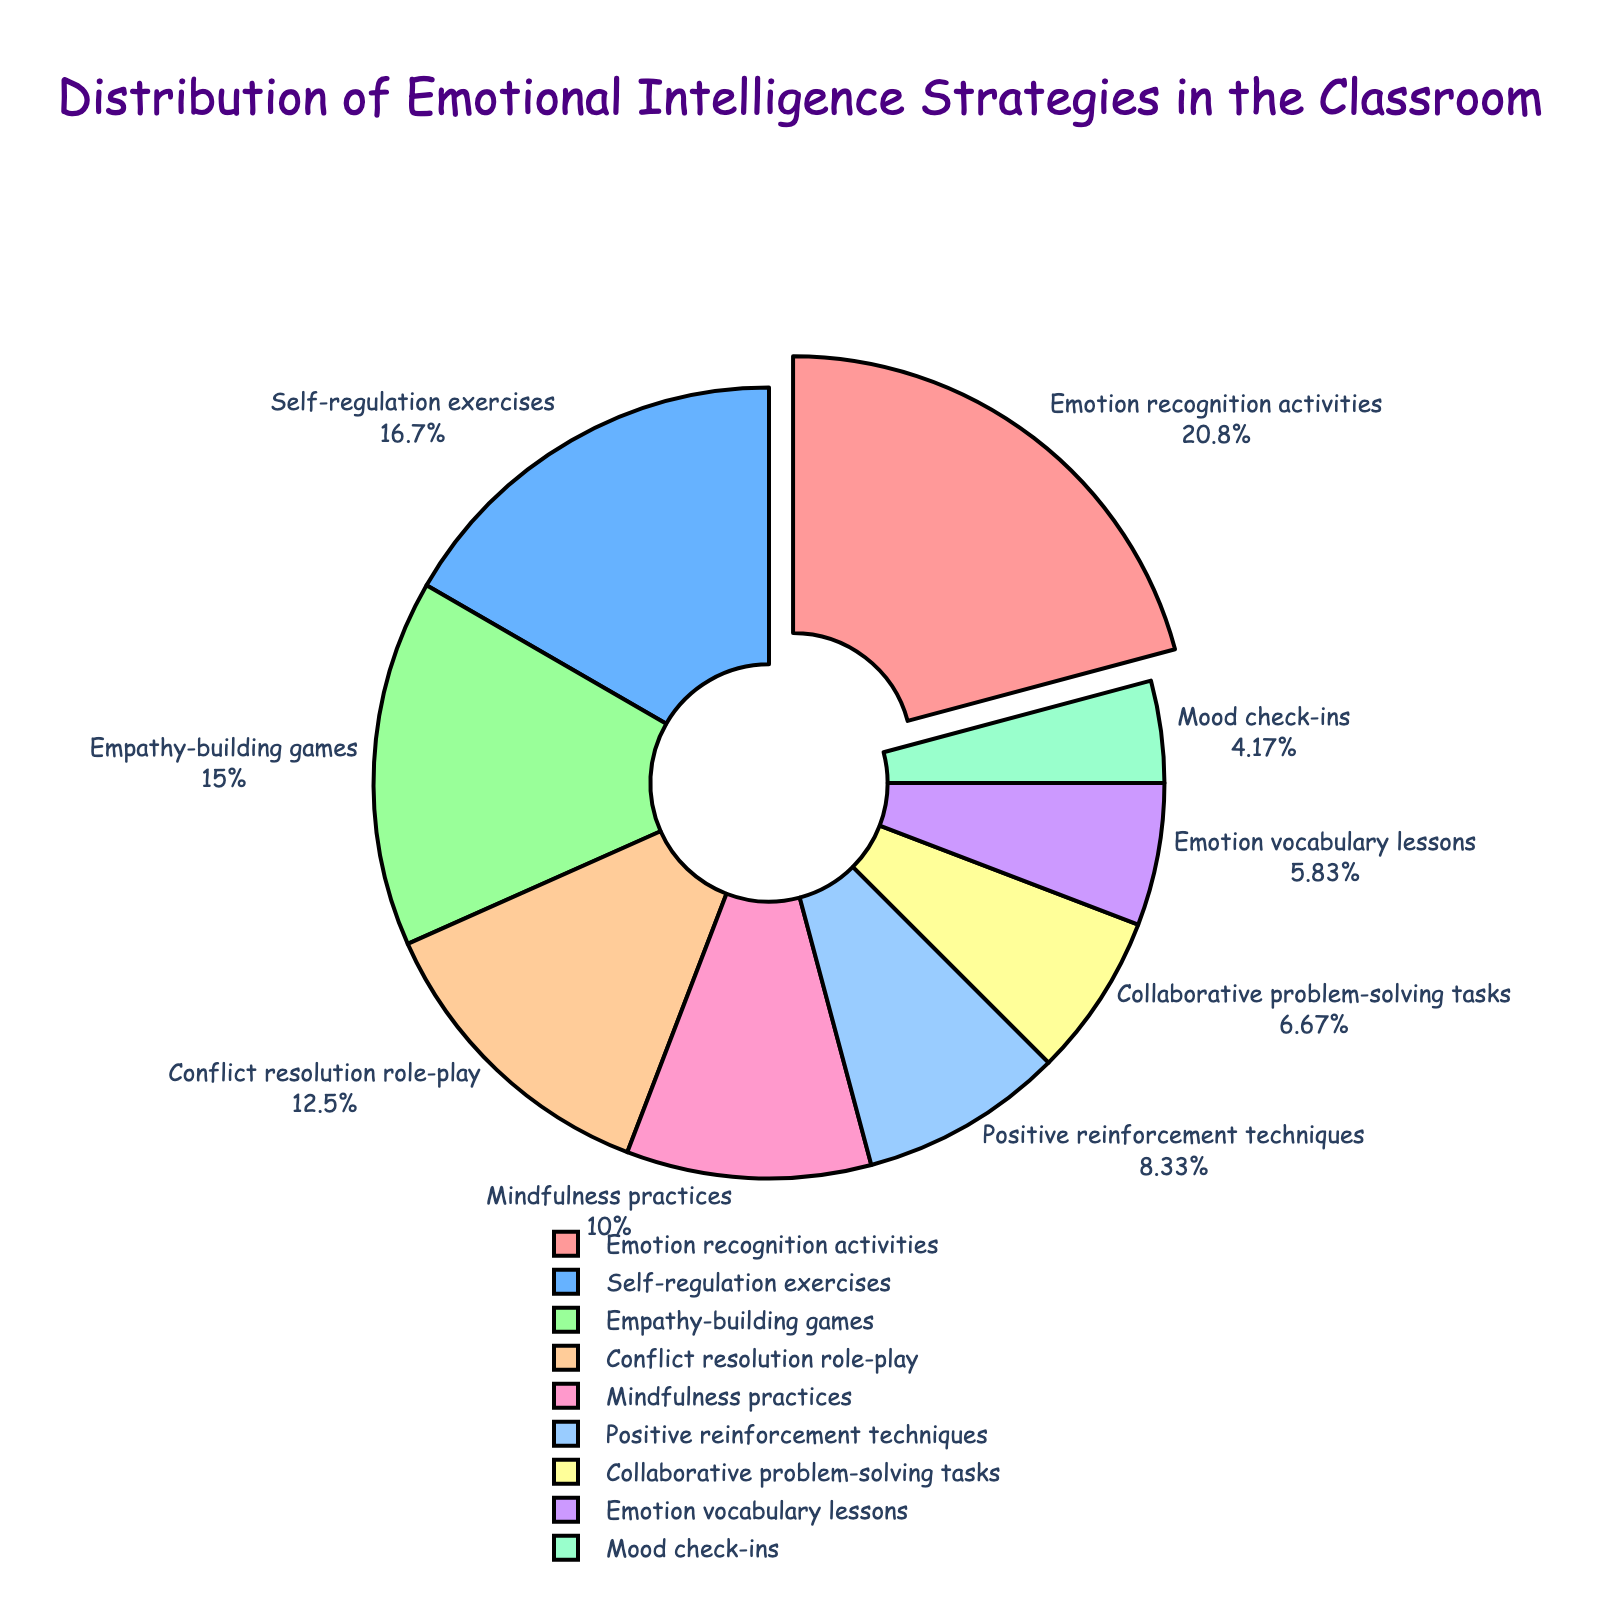What is the most frequently used emotional intelligence strategy in the classroom according to the pie chart? The pie chart shows various percentages corresponding to each strategy. Look for the slice with the largest percentage, which is 25% for Emotion recognition activities.
Answer: Emotion recognition activities How much higher is the percentage of Emotion recognition activities compared to Positive reinforcement techniques? The percentage for Emotion recognition activities is 25% and for Positive reinforcement techniques is 10%. The difference is 25% - 10% = 15%.
Answer: 15% Which strategy is least frequently used according to the pie chart? The strategy with the smallest percentage represents the least used one. Mood check-ins show the smallest percentage at 5%.
Answer: Mood check-ins If you combine the percentages for Empathy-building games and Conflict resolution role-play, what will be the total? The percentage for Empathy-building games is 18% and for Conflict resolution role-play is 15%. Adding them together, 18% + 15% = 33%.
Answer: 33% Which strategies together make up exactly half of the emotional intelligence strategies used in the classroom? Combining strategies with their percentages to add up to 50%: Emotion recognition activities (25%) + Self-regulation exercises (20%) + Mood check-ins (5%) = 25% + 20% + 5% = 50%.
Answer: Emotion recognition activities, Self-regulation exercises, Mood check-ins How does the percentage of Self-regulation exercises compare to Mindfulness practices? Self-regulation exercises occupy 20% of the chart and Mindfulness practices occupy 12%. The percentage of Self-regulation exercises is greater than that of Mindfulness practices.
Answer: Greater What is the combined percentage of all the strategies except for the top three? The top three strategies are Emotion recognition activities (25%), Self-regulation exercises (20%), and Empathy-building games (18%). Their combined percentage is 25% + 20% + 18% = 63%. Subtract this from 100% to find the sum of the others: 100% - 63% = 37%.
Answer: 37% What is the percentage difference between the most and least frequently used strategies? The most frequently used strategy is Emotion recognition activities at 25%, and the least frequently used is Mood check-ins at 5%. The difference is 25% - 5% = 20%.
Answer: 20% What color is used to represent Conflict resolution role-play in the pie chart? Conflict resolution role-play occupies a specific slice that is colored. Identify the color of this slice. It is generally helpful to refer to visual attributes but since actual colors are not specified in the query, refer to the 4th color choice in the code provided: '#FFCC99'.
Answer: (#FFCC99 color or description if specified by a visual) 